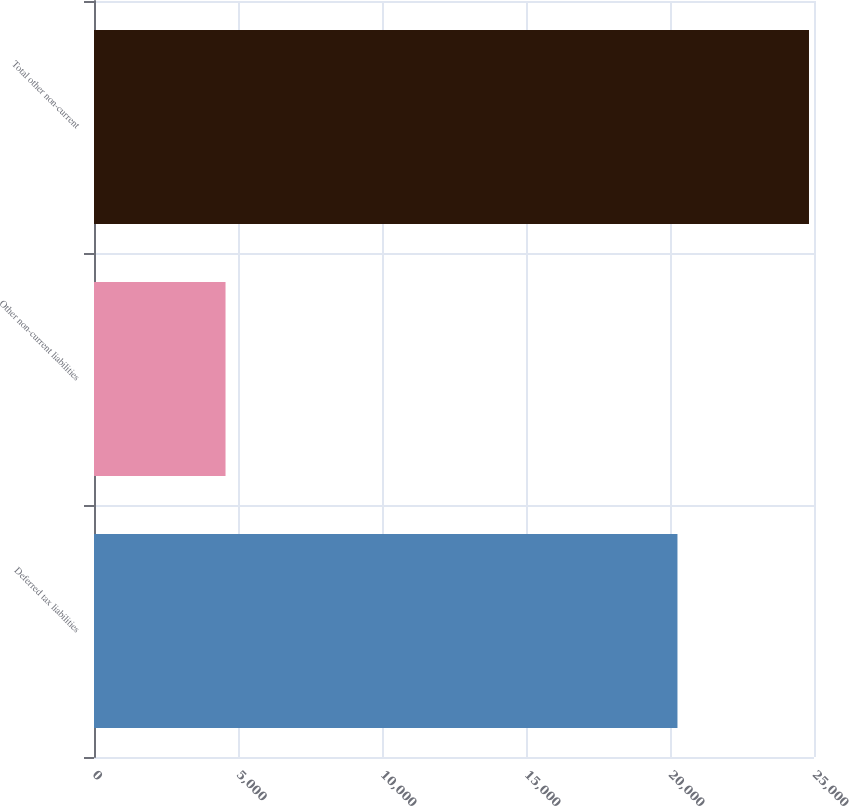Convert chart. <chart><loc_0><loc_0><loc_500><loc_500><bar_chart><fcel>Deferred tax liabilities<fcel>Other non-current liabilities<fcel>Total other non-current<nl><fcel>20259<fcel>4567<fcel>24826<nl></chart> 